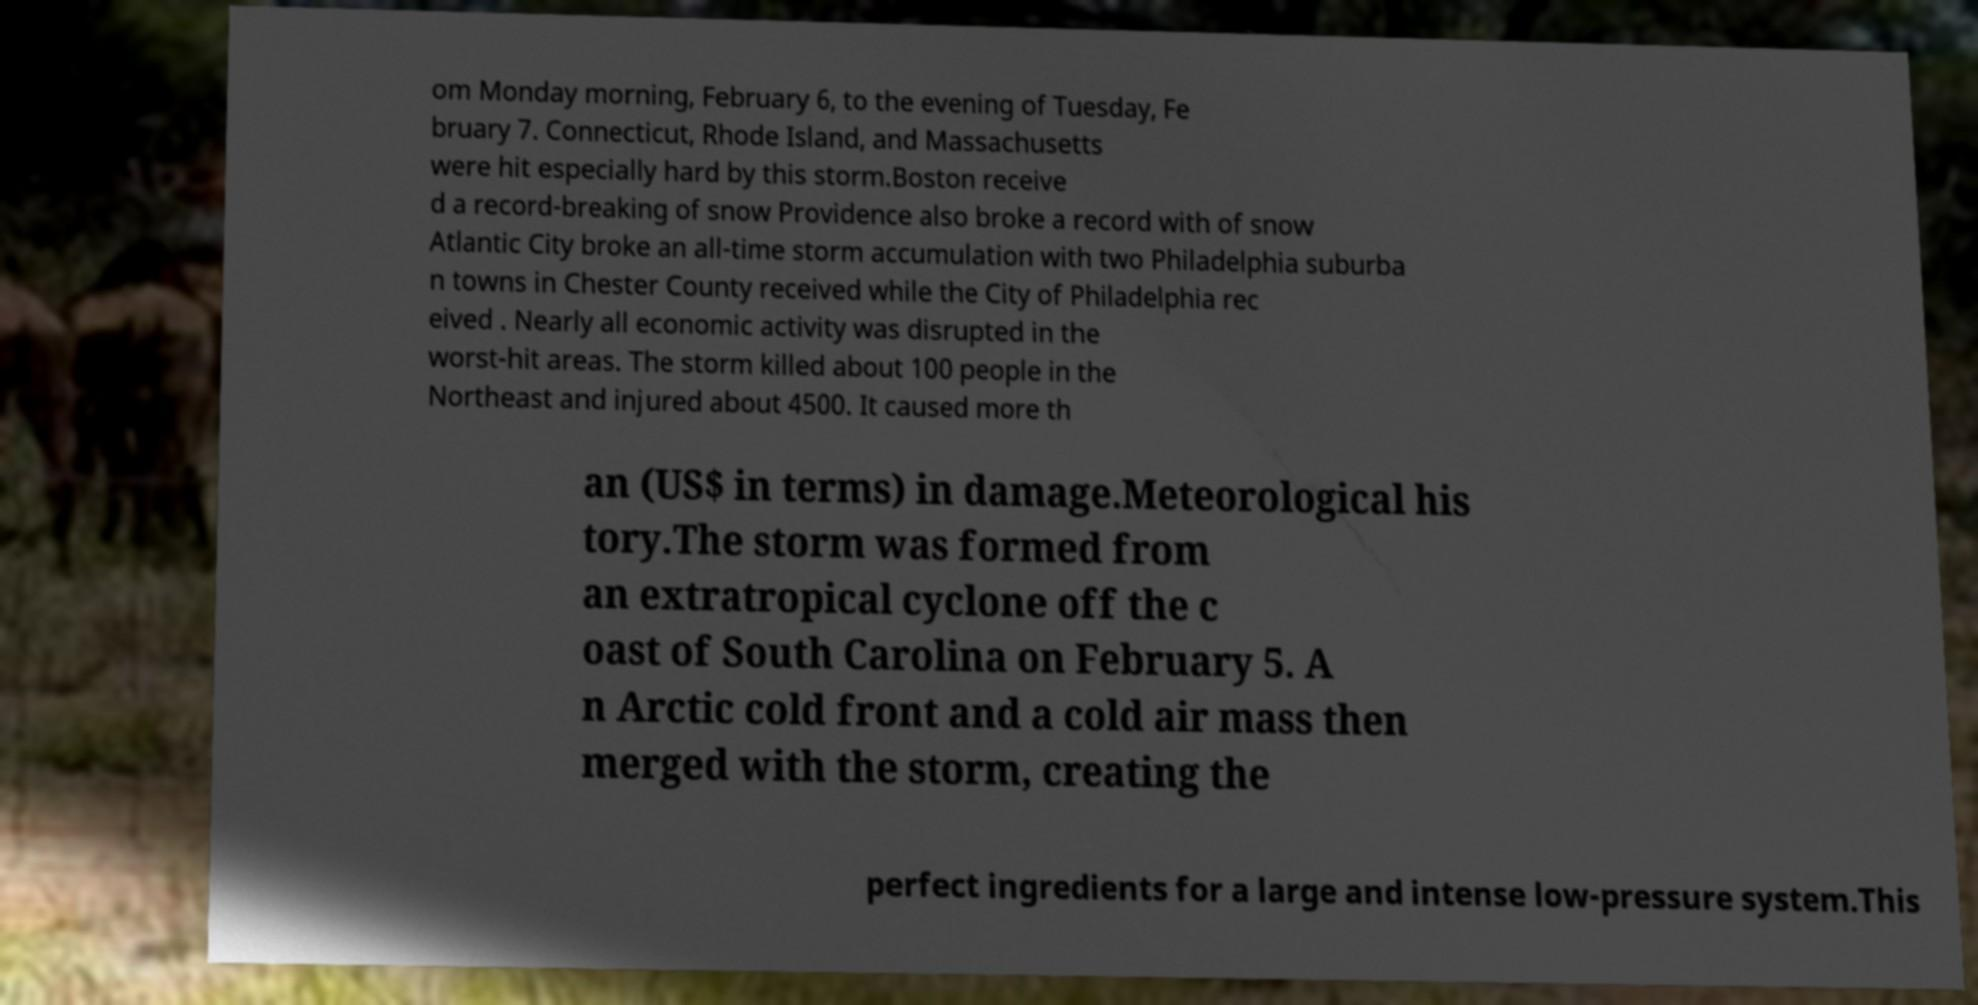Can you accurately transcribe the text from the provided image for me? om Monday morning, February 6, to the evening of Tuesday, Fe bruary 7. Connecticut, Rhode Island, and Massachusetts were hit especially hard by this storm.Boston receive d a record-breaking of snow Providence also broke a record with of snow Atlantic City broke an all-time storm accumulation with two Philadelphia suburba n towns in Chester County received while the City of Philadelphia rec eived . Nearly all economic activity was disrupted in the worst-hit areas. The storm killed about 100 people in the Northeast and injured about 4500. It caused more th an (US$ in terms) in damage.Meteorological his tory.The storm was formed from an extratropical cyclone off the c oast of South Carolina on February 5. A n Arctic cold front and a cold air mass then merged with the storm, creating the perfect ingredients for a large and intense low-pressure system.This 